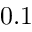Convert formula to latex. <formula><loc_0><loc_0><loc_500><loc_500>0 . 1</formula> 